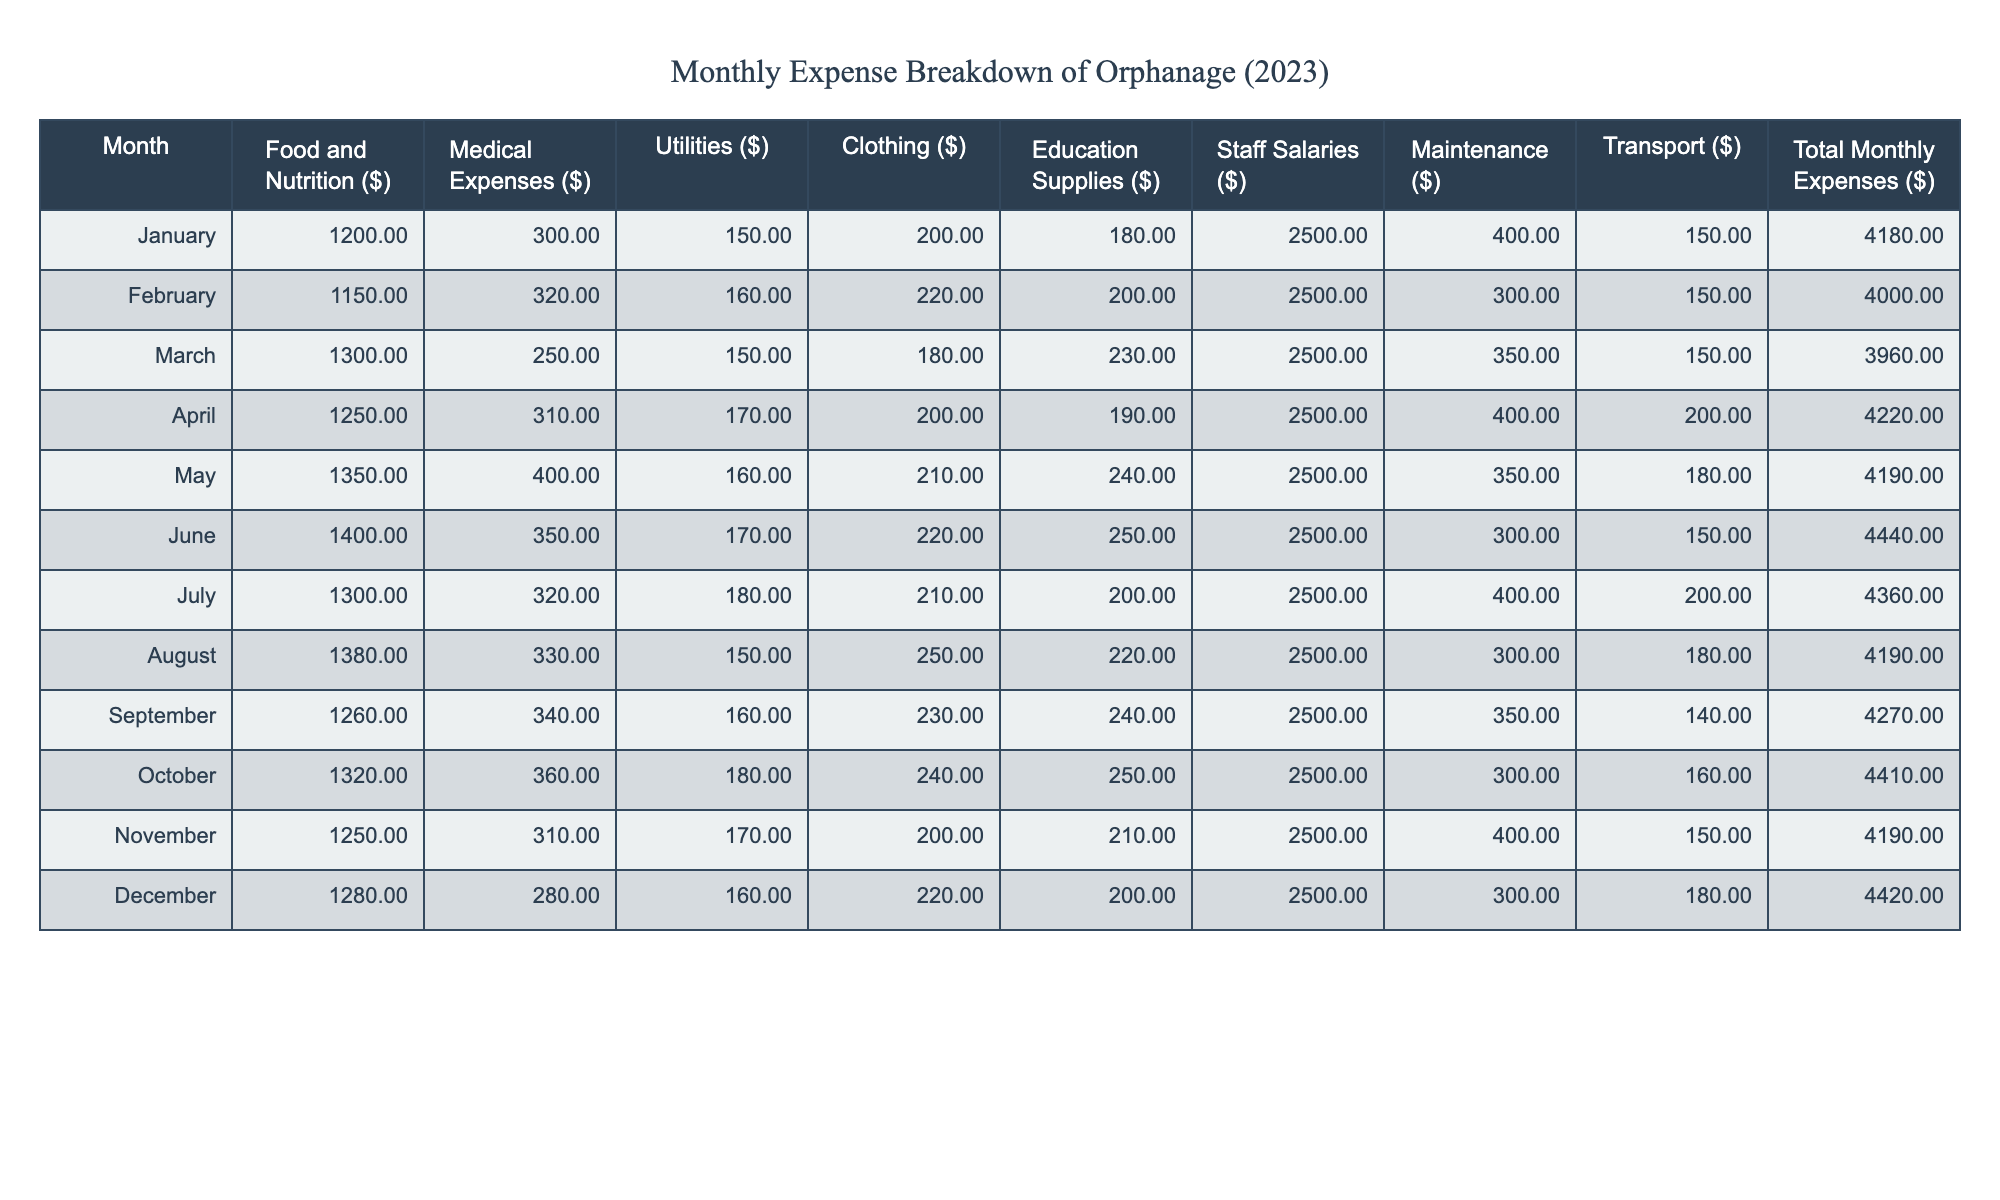What are the total monthly expenses in July? The table shows the total monthly expenses for each month. For July, the value is located in the "Total Monthly Expenses ($)" column corresponding to the row for July, which is 4360.
Answer: 4360 What was the highest medical expense recorded in any month? To find the highest medical expense, look down the "Medical Expenses ($)" column and identify the maximum value. The values are 300, 320, 250, 310, 400, 350, 320, 330, 340, 360, 310, and 280. The maximum value is 400, which occurred in May.
Answer: 400 Which month had the lowest total expenses and what was the amount? To find the month with the lowest total expenses, examine the "Total Monthly Expenses ($)" column. The values are 4180, 4000, 3960, 4220, 4190, 4440, 4360, 4190, 4270, 4410, 4190, and 4420. The minimum value is 3960, which was recorded in March.
Answer: 3960 What was the average amount spent on food and nutrition over the year? First, sum the values in the "Food and Nutrition ($)" column for all months: 1200 + 1150 + 1300 + 1250 + 1350 + 1400 + 1300 + 1380 + 1260 + 1320 + 1250 + 1280 = 15600. There are 12 months, so the average is 15600/12 = 1300.
Answer: 1300 Did the clothing expenses ever exceed $250 in any month? To answer this, check the "Clothing ($)" column for each month's value: 200, 220, 180, 200, 210, 220, 210, 250, 230, 240, 200, and 220. Since the maximum value is 250, it is true that clothing expenses exceeded $250 in August.
Answer: Yes Which month had the highest total expenses, and what were the individual components? To find the month with the highest total expenses, check the "Total Monthly Expenses ($)" column. The maximum value found is 4440, which occurred in June. The individual components for June are: Food and Nutrition: 1400, Medical Expenses: 350, Utilities: 170, Clothing: 220, Education Supplies: 250, Staff Salaries: 2500, Maintenance: 300, Transport: 150.
Answer: June: 4440 (Food: 1400, Medical: 350, Utilities: 170, Clothing: 220, Educ. Supplies: 250, Salaries: 2500, Maintenance: 300, Transport: 150) What was the total cost of education supplies over the year? To find the total for education supplies, sum the values from the "Education Supplies ($)" column: 180 + 200 + 230 + 190 + 240 + 250 + 200 + 220 + 240 + 250 + 210 + 200 = 2760.
Answer: 2760 Was there any month where staff salaries were less than $2500? Checking the "Staff Salaries ($)" column reveals that all values are 2500. Thus, staff salaries never fell below that amount.
Answer: No 